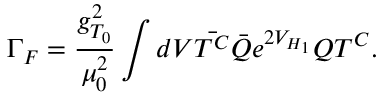<formula> <loc_0><loc_0><loc_500><loc_500>\Gamma _ { F } = \frac { g _ { T _ { 0 } } ^ { 2 } } { \mu _ { 0 } ^ { 2 } } \int d V \bar { T ^ { C } } \bar { Q } e ^ { 2 V _ { H _ { 1 } } } Q T ^ { C } .</formula> 